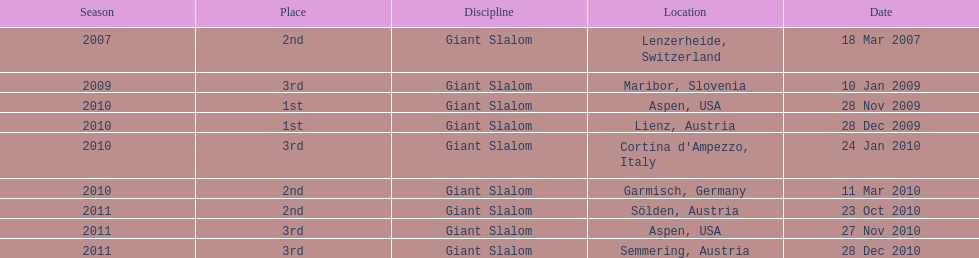What is the total number of her 2nd place finishes on the list? 3. 